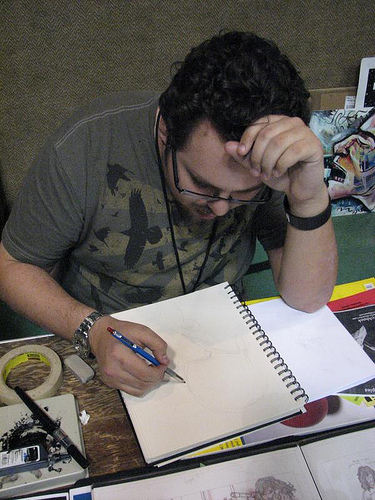<image>
Can you confirm if the man is to the left of the textbook? No. The man is not to the left of the textbook. From this viewpoint, they have a different horizontal relationship. Is the man in front of the paper? No. The man is not in front of the paper. The spatial positioning shows a different relationship between these objects. 